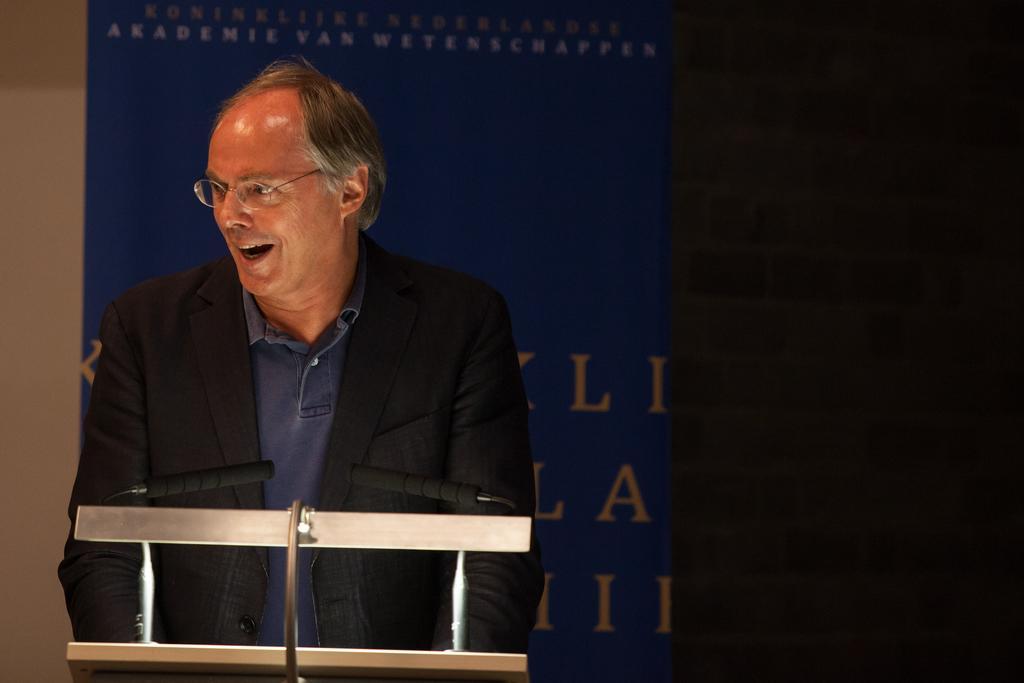Could you give a brief overview of what you see in this image? In this picture I can see there is a man standing and is wearing spectacles and is looking on the left side, there are microphones here and in the background there is a banner. 